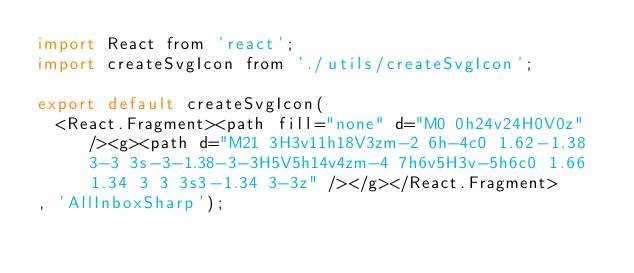<code> <loc_0><loc_0><loc_500><loc_500><_JavaScript_>import React from 'react';
import createSvgIcon from './utils/createSvgIcon';

export default createSvgIcon(
  <React.Fragment><path fill="none" d="M0 0h24v24H0V0z" /><g><path d="M21 3H3v11h18V3zm-2 6h-4c0 1.62-1.38 3-3 3s-3-1.38-3-3H5V5h14v4zm-4 7h6v5H3v-5h6c0 1.66 1.34 3 3 3s3-1.34 3-3z" /></g></React.Fragment>
, 'AllInboxSharp');
</code> 